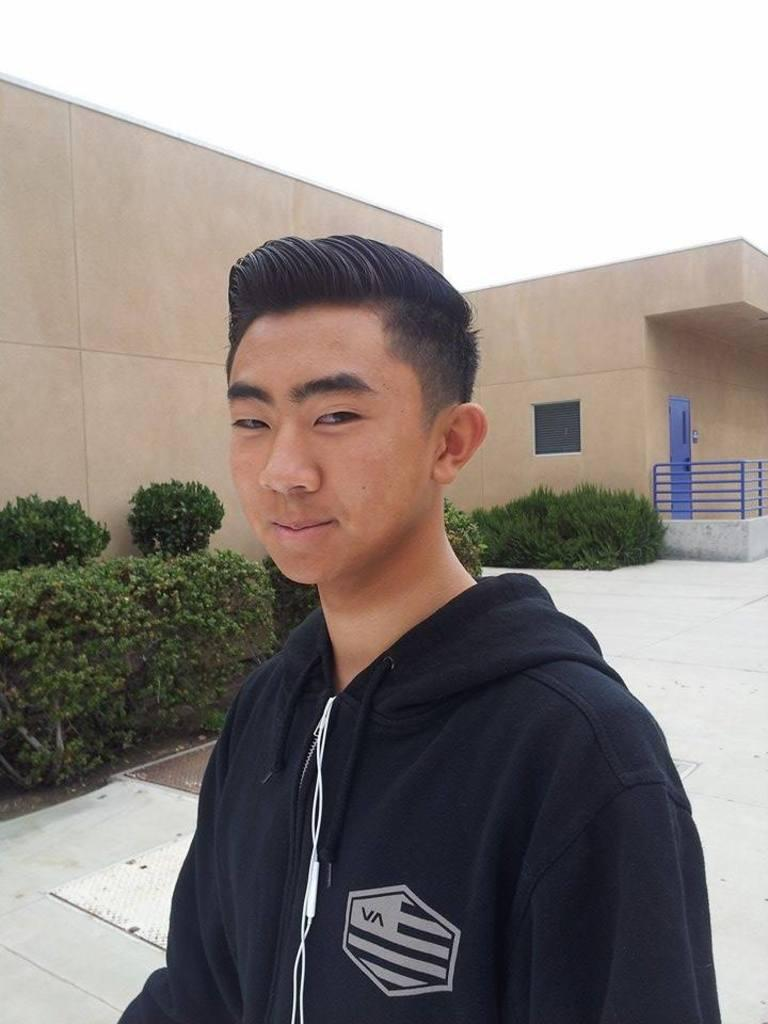What is the person in the image wearing? The person in the image is wearing a black jacket. What can be seen in the middle of the image? There are houses in the middle of the image. What type of vegetation is in front of the houses? There are bushes in front of the houses. What is visible at the top of the image? The sky is visible at the top of the image. Can you tell me how many times the person in the image shakes their ear? There is no indication in the image that the person is shaking their ear, so it cannot be determined from the picture. 